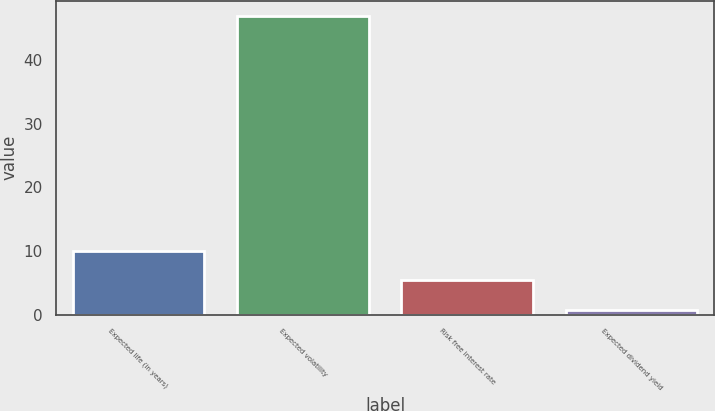<chart> <loc_0><loc_0><loc_500><loc_500><bar_chart><fcel>Expected life (in years)<fcel>Expected volatility<fcel>Risk free interest rate<fcel>Expected dividend yield<nl><fcel>10.01<fcel>47<fcel>5.39<fcel>0.77<nl></chart> 